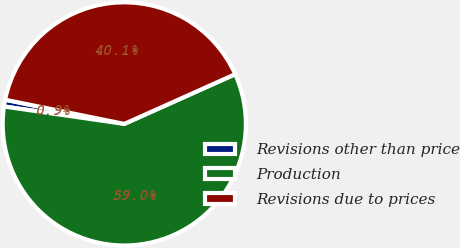<chart> <loc_0><loc_0><loc_500><loc_500><pie_chart><fcel>Revisions other than price<fcel>Production<fcel>Revisions due to prices<nl><fcel>0.9%<fcel>58.99%<fcel>40.1%<nl></chart> 